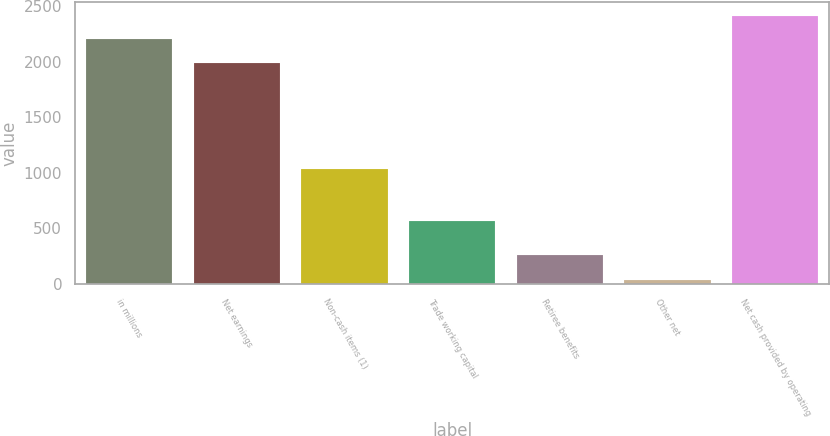<chart> <loc_0><loc_0><loc_500><loc_500><bar_chart><fcel>in millions<fcel>Net earnings<fcel>Non-cash items (1)<fcel>Trade working capital<fcel>Retiree benefits<fcel>Other net<fcel>Net cash provided by operating<nl><fcel>2202.6<fcel>1990<fcel>1035<fcel>564<fcel>263<fcel>36<fcel>2415.2<nl></chart> 